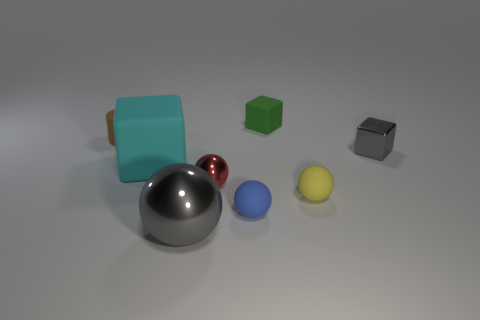Add 1 big cyan rubber cubes. How many objects exist? 9 Subtract all metallic cubes. How many cubes are left? 2 Subtract all green blocks. How many blocks are left? 2 Subtract all cylinders. How many objects are left? 7 Subtract 3 blocks. How many blocks are left? 0 Add 6 large blocks. How many large blocks are left? 7 Add 5 matte cubes. How many matte cubes exist? 7 Subtract 0 gray cylinders. How many objects are left? 8 Subtract all yellow blocks. Subtract all purple cylinders. How many blocks are left? 3 Subtract all blue cylinders. How many red spheres are left? 1 